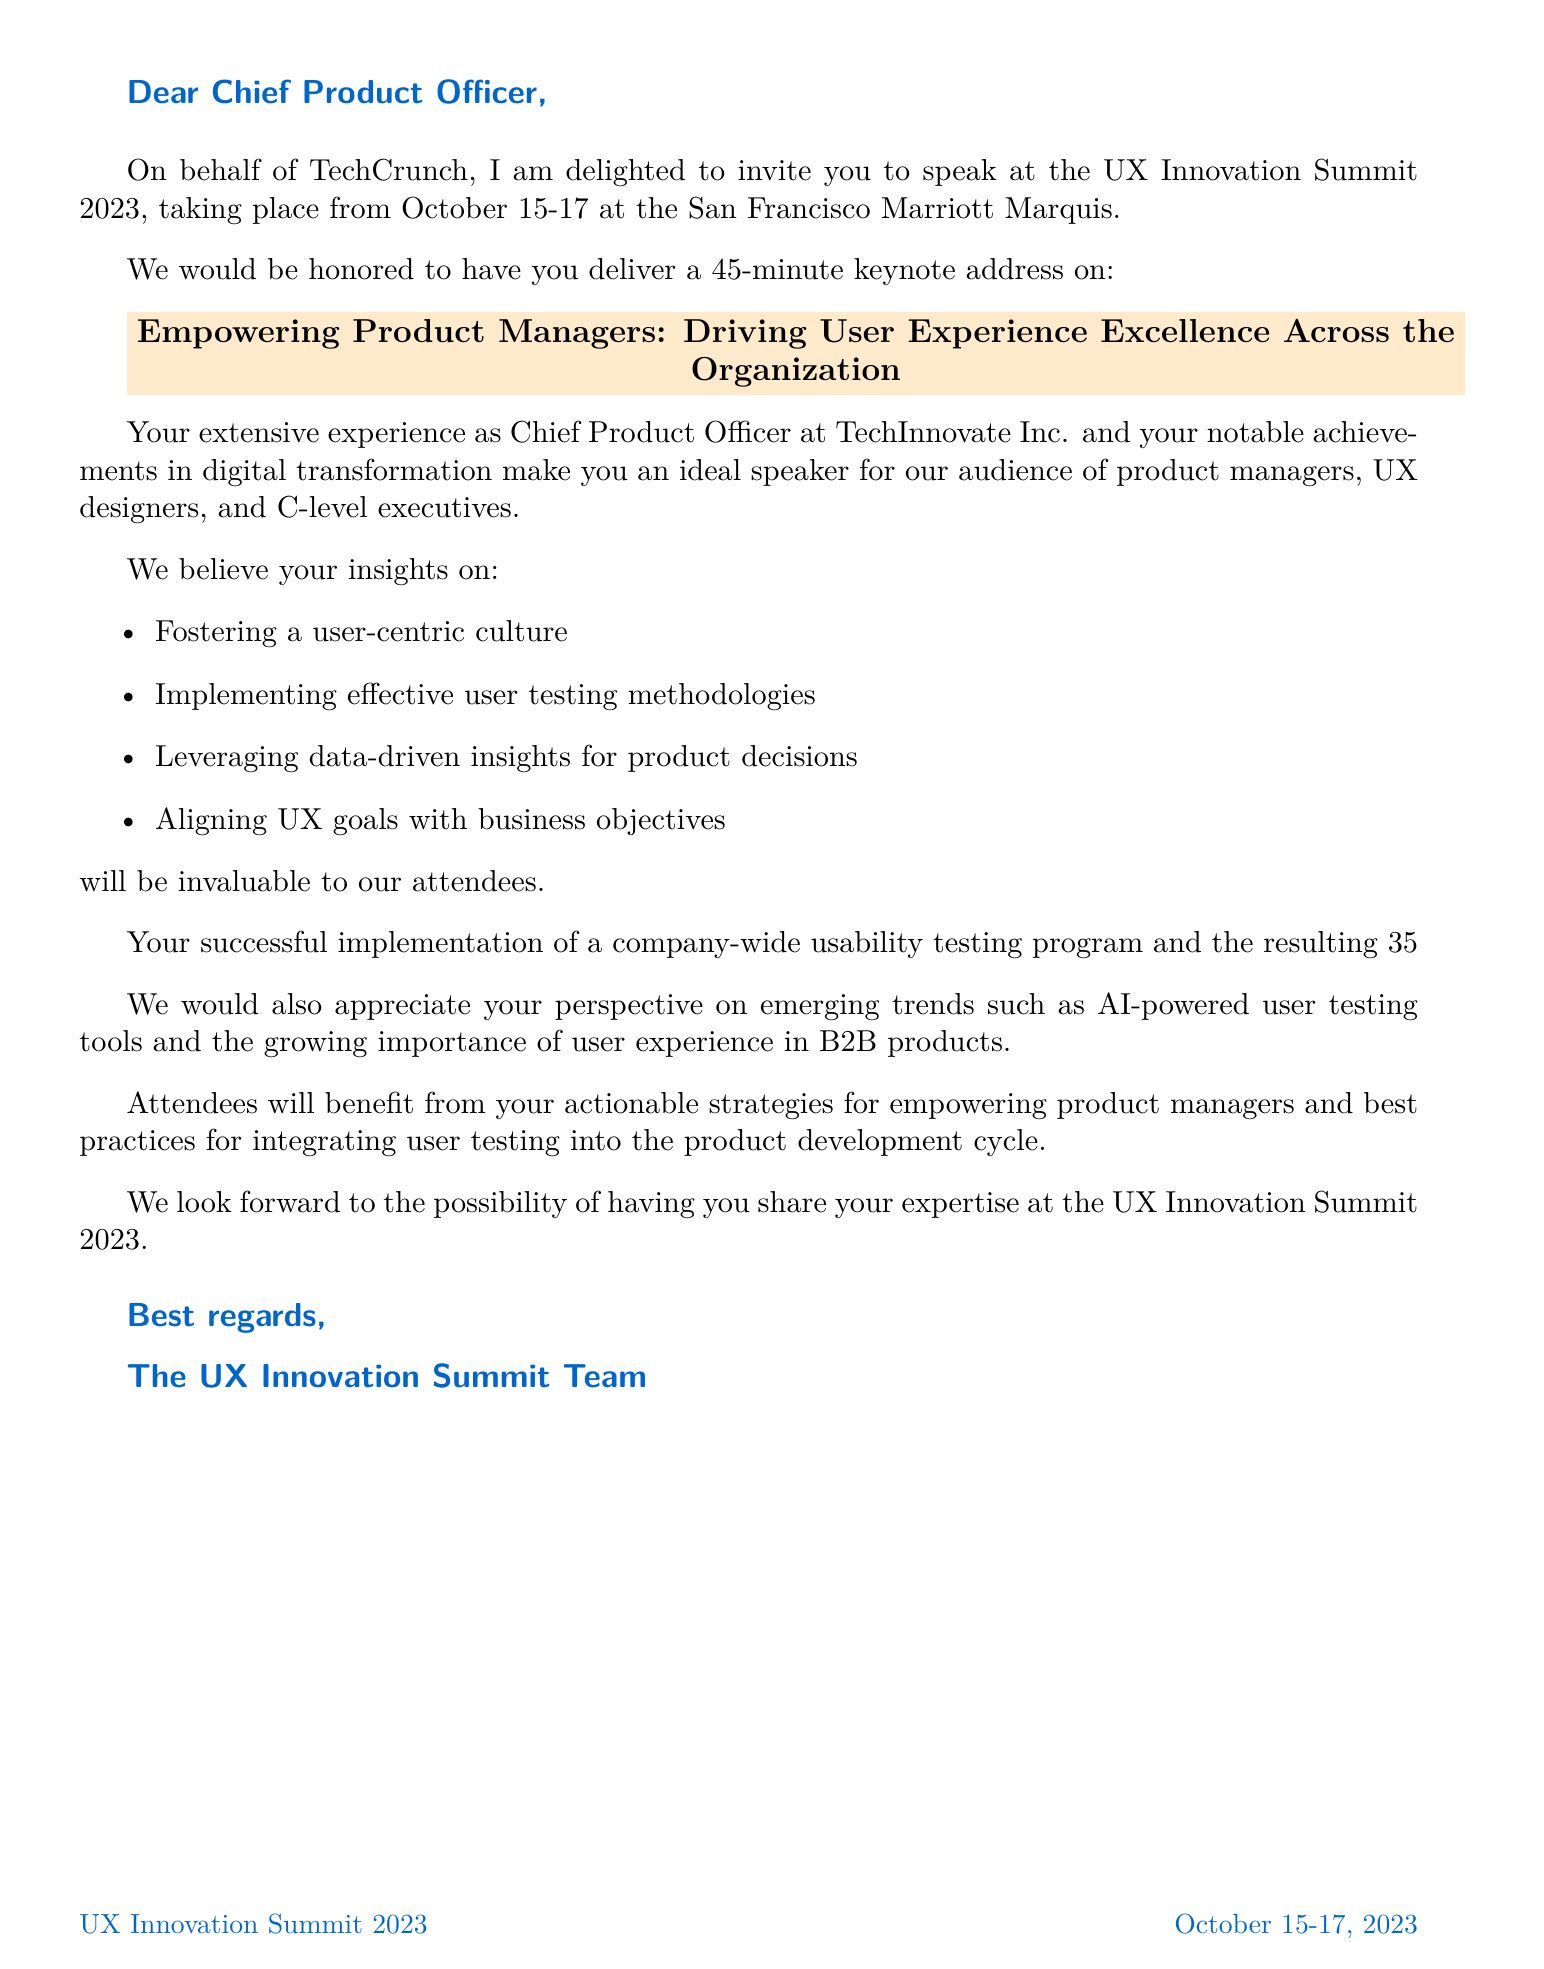What is the name of the conference? The name of the conference is mentioned at the beginning of the document.
Answer: UX Innovation Summit 2023 When does the conference take place? The document specifies the dates of the conference in the opening paragraphs.
Answer: October 15-17, 2023 Where is the conference located? The location of the conference is provided in the document.
Answer: San Francisco Marriott Marquis What is the duration of the keynote address? The document specifies the duration of the speaking opportunity.
Answer: 45-minute Who is the main audience for the keynote session? The target audience for the session is listed in the document.
Answer: Product managers, UX designers, and C-level executives What percentage increase in user satisfaction scores was achieved? This information is listed under personal achievements in the document.
Answer: 35% Which company is mentioned in relation to a case study about user productivity? One of the relevant case studies provided in the document mentions this company.
Answer: Salesforce What trend is related to AI in the document? The document discusses the rising trend in user testing tools.
Answer: Rise of AI-powered user testing tools What is one of the follow-up resources mentioned for attendees? The document lists potential follow-up resources at the end.
Answer: Exclusive white paper on 'The ROI of User-Centric Product Development' 